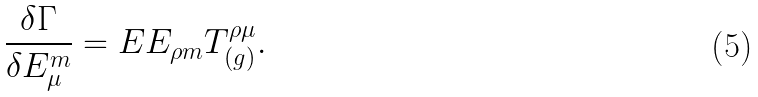Convert formula to latex. <formula><loc_0><loc_0><loc_500><loc_500>\frac { \delta \Gamma } { \delta E ^ { m } _ { \mu } } = E E _ { \rho m } T _ { ( g ) } ^ { \rho \mu } .</formula> 